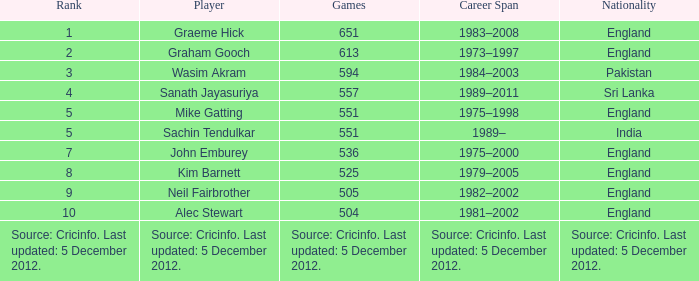What is Graham Gooch's nationality? England. 